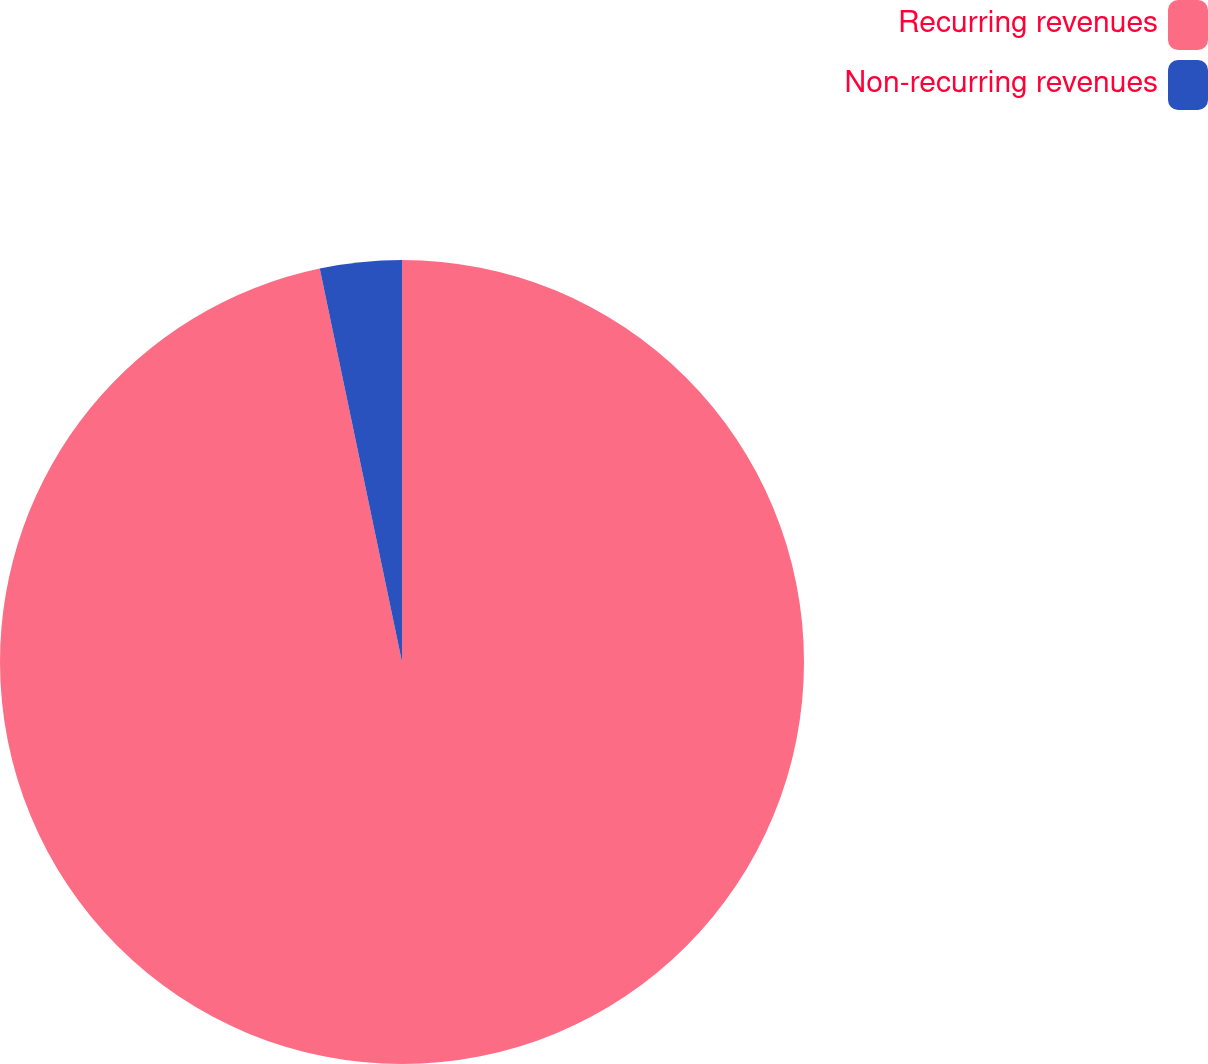<chart> <loc_0><loc_0><loc_500><loc_500><pie_chart><fcel>Recurring revenues<fcel>Non-recurring revenues<nl><fcel>96.72%<fcel>3.28%<nl></chart> 